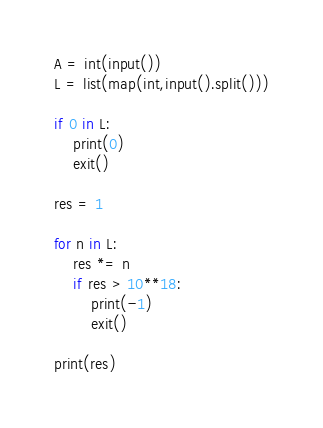<code> <loc_0><loc_0><loc_500><loc_500><_Python_>A = int(input())
L = list(map(int,input().split()))

if 0 in L:
    print(0)
    exit()

res = 1

for n in L:
    res *= n
    if res > 10**18:
        print(-1)
        exit()
    
print(res)</code> 